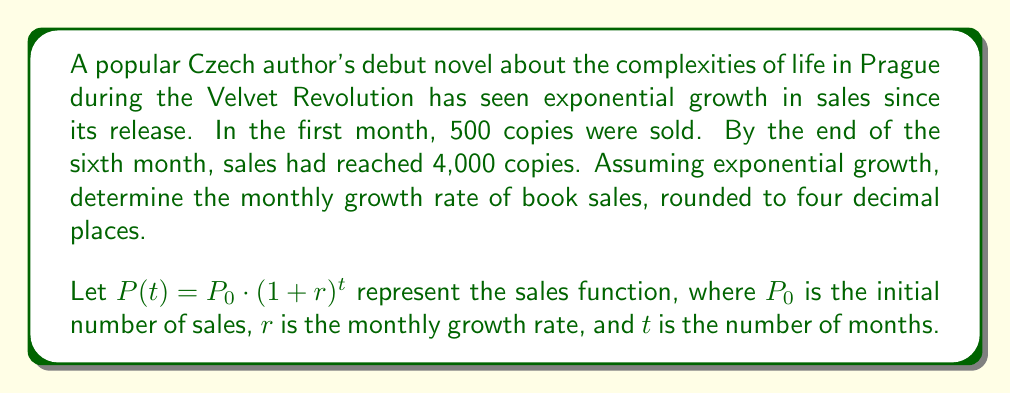Can you solve this math problem? To solve this problem, we'll use the exponential growth formula:

$$P(t) = P_0 \cdot (1+r)^t$$

Given:
- Initial sales (month 0): $P_0 = 500$
- Sales after 6 months: $P(6) = 4,000$
- Time period: $t = 6$ months

Step 1: Substitute the known values into the formula.
$$4,000 = 500 \cdot (1+r)^6$$

Step 2: Divide both sides by 500.
$$8 = (1+r)^6$$

Step 3: Take the 6th root of both sides.
$$\sqrt[6]{8} = 1+r$$

Step 4: Subtract 1 from both sides to isolate $r$.
$$\sqrt[6]{8} - 1 = r$$

Step 5: Calculate the value of $r$ using a calculator.
$$r \approx 1.4142135624 - 1 = 0.4142135624$$

Step 6: Round to four decimal places.
$$r \approx 0.4142$$

Therefore, the monthly growth rate is approximately 0.4142 or 41.42%.
Answer: $r \approx 0.4142$ or $41.42\%$ 